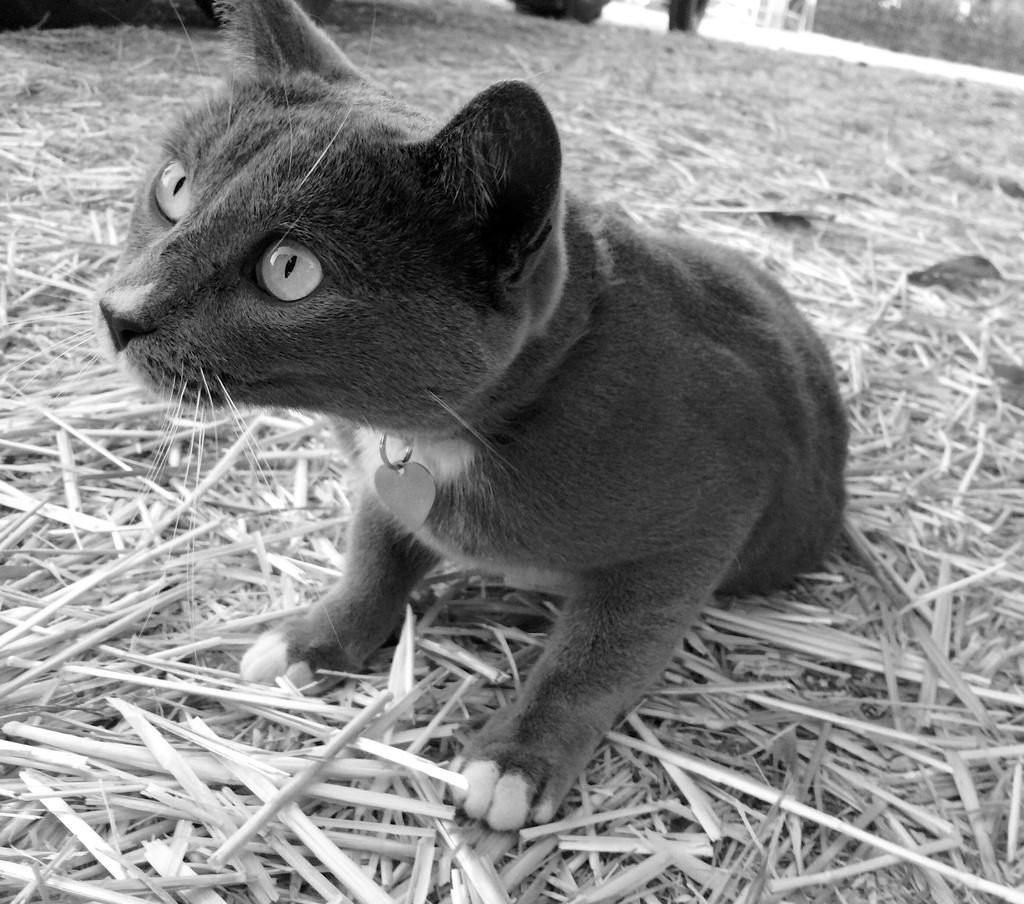How would you summarize this image in a sentence or two? In this image we can see an animal. There are many plants and dry grass in the image. 